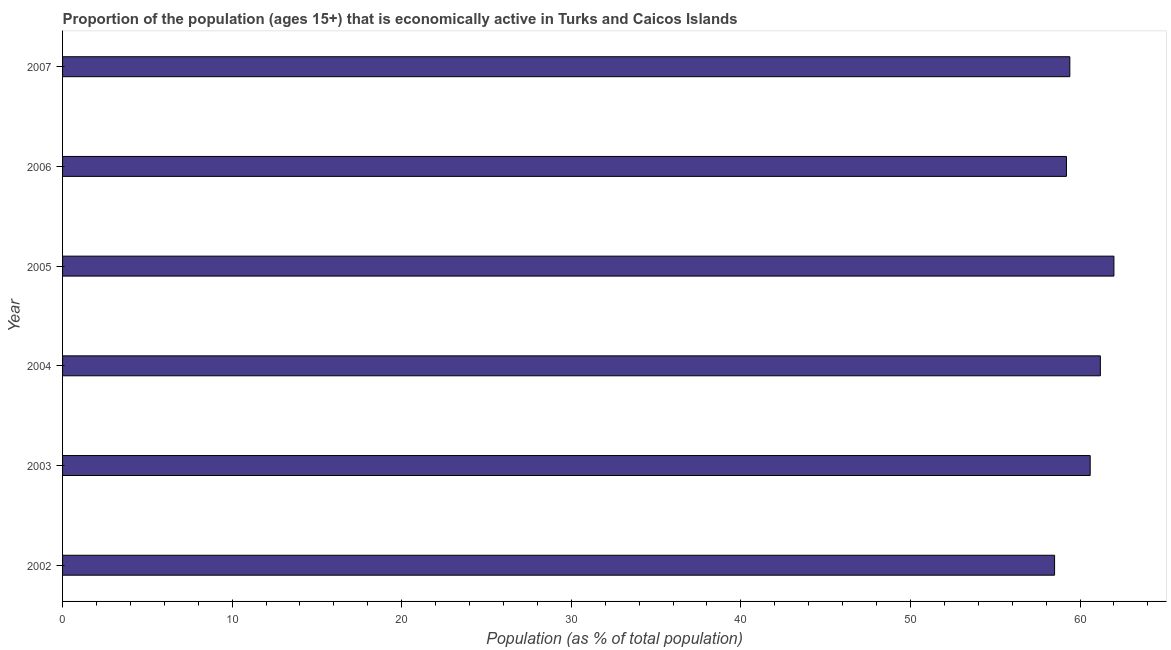Does the graph contain grids?
Your answer should be very brief. No. What is the title of the graph?
Make the answer very short. Proportion of the population (ages 15+) that is economically active in Turks and Caicos Islands. What is the label or title of the X-axis?
Ensure brevity in your answer.  Population (as % of total population). What is the percentage of economically active population in 2005?
Offer a terse response. 62. Across all years, what is the minimum percentage of economically active population?
Make the answer very short. 58.5. In which year was the percentage of economically active population maximum?
Offer a terse response. 2005. What is the sum of the percentage of economically active population?
Provide a short and direct response. 360.9. What is the average percentage of economically active population per year?
Your answer should be very brief. 60.15. In how many years, is the percentage of economically active population greater than 54 %?
Give a very brief answer. 6. Do a majority of the years between 2004 and 2005 (inclusive) have percentage of economically active population greater than 44 %?
Provide a short and direct response. Yes. What is the ratio of the percentage of economically active population in 2006 to that in 2007?
Your response must be concise. 1. Is the difference between the percentage of economically active population in 2004 and 2006 greater than the difference between any two years?
Keep it short and to the point. No. Is the sum of the percentage of economically active population in 2003 and 2007 greater than the maximum percentage of economically active population across all years?
Your answer should be very brief. Yes. What is the difference between the highest and the lowest percentage of economically active population?
Offer a terse response. 3.5. In how many years, is the percentage of economically active population greater than the average percentage of economically active population taken over all years?
Offer a very short reply. 3. How many bars are there?
Ensure brevity in your answer.  6. Are all the bars in the graph horizontal?
Your response must be concise. Yes. What is the difference between two consecutive major ticks on the X-axis?
Your response must be concise. 10. What is the Population (as % of total population) in 2002?
Your answer should be compact. 58.5. What is the Population (as % of total population) in 2003?
Your response must be concise. 60.6. What is the Population (as % of total population) in 2004?
Offer a very short reply. 61.2. What is the Population (as % of total population) of 2006?
Your response must be concise. 59.2. What is the Population (as % of total population) of 2007?
Give a very brief answer. 59.4. What is the difference between the Population (as % of total population) in 2002 and 2006?
Make the answer very short. -0.7. What is the difference between the Population (as % of total population) in 2003 and 2005?
Provide a succinct answer. -1.4. What is the difference between the Population (as % of total population) in 2003 and 2007?
Offer a very short reply. 1.2. What is the difference between the Population (as % of total population) in 2004 and 2005?
Provide a short and direct response. -0.8. What is the difference between the Population (as % of total population) in 2005 and 2006?
Your answer should be very brief. 2.8. What is the ratio of the Population (as % of total population) in 2002 to that in 2003?
Provide a succinct answer. 0.96. What is the ratio of the Population (as % of total population) in 2002 to that in 2004?
Make the answer very short. 0.96. What is the ratio of the Population (as % of total population) in 2002 to that in 2005?
Your answer should be very brief. 0.94. What is the ratio of the Population (as % of total population) in 2002 to that in 2006?
Your answer should be very brief. 0.99. What is the ratio of the Population (as % of total population) in 2003 to that in 2005?
Give a very brief answer. 0.98. What is the ratio of the Population (as % of total population) in 2004 to that in 2006?
Keep it short and to the point. 1.03. What is the ratio of the Population (as % of total population) in 2004 to that in 2007?
Make the answer very short. 1.03. What is the ratio of the Population (as % of total population) in 2005 to that in 2006?
Give a very brief answer. 1.05. What is the ratio of the Population (as % of total population) in 2005 to that in 2007?
Provide a short and direct response. 1.04. What is the ratio of the Population (as % of total population) in 2006 to that in 2007?
Keep it short and to the point. 1. 